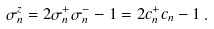Convert formula to latex. <formula><loc_0><loc_0><loc_500><loc_500>\sigma _ { n } ^ { z } = 2 \sigma _ { n } ^ { + } \sigma _ { n } ^ { - } - 1 = 2 c _ { n } ^ { + } c _ { n } - 1 \, .</formula> 